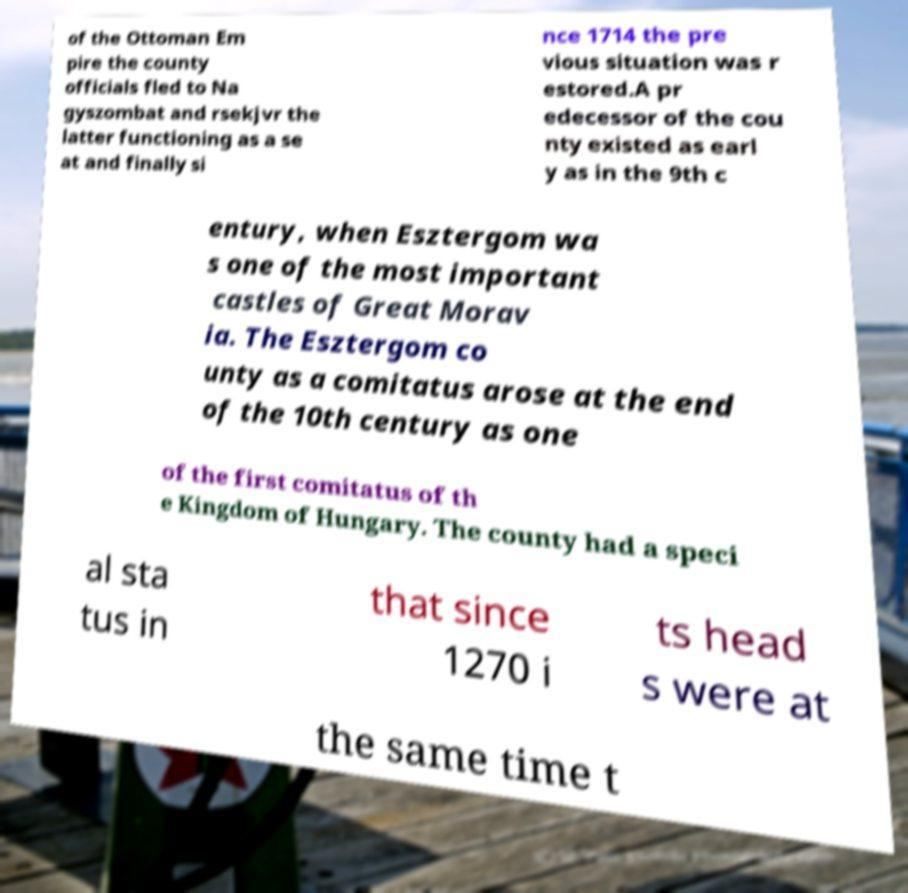For documentation purposes, I need the text within this image transcribed. Could you provide that? of the Ottoman Em pire the county officials fled to Na gyszombat and rsekjvr the latter functioning as a se at and finally si nce 1714 the pre vious situation was r estored.A pr edecessor of the cou nty existed as earl y as in the 9th c entury, when Esztergom wa s one of the most important castles of Great Morav ia. The Esztergom co unty as a comitatus arose at the end of the 10th century as one of the first comitatus of th e Kingdom of Hungary. The county had a speci al sta tus in that since 1270 i ts head s were at the same time t 